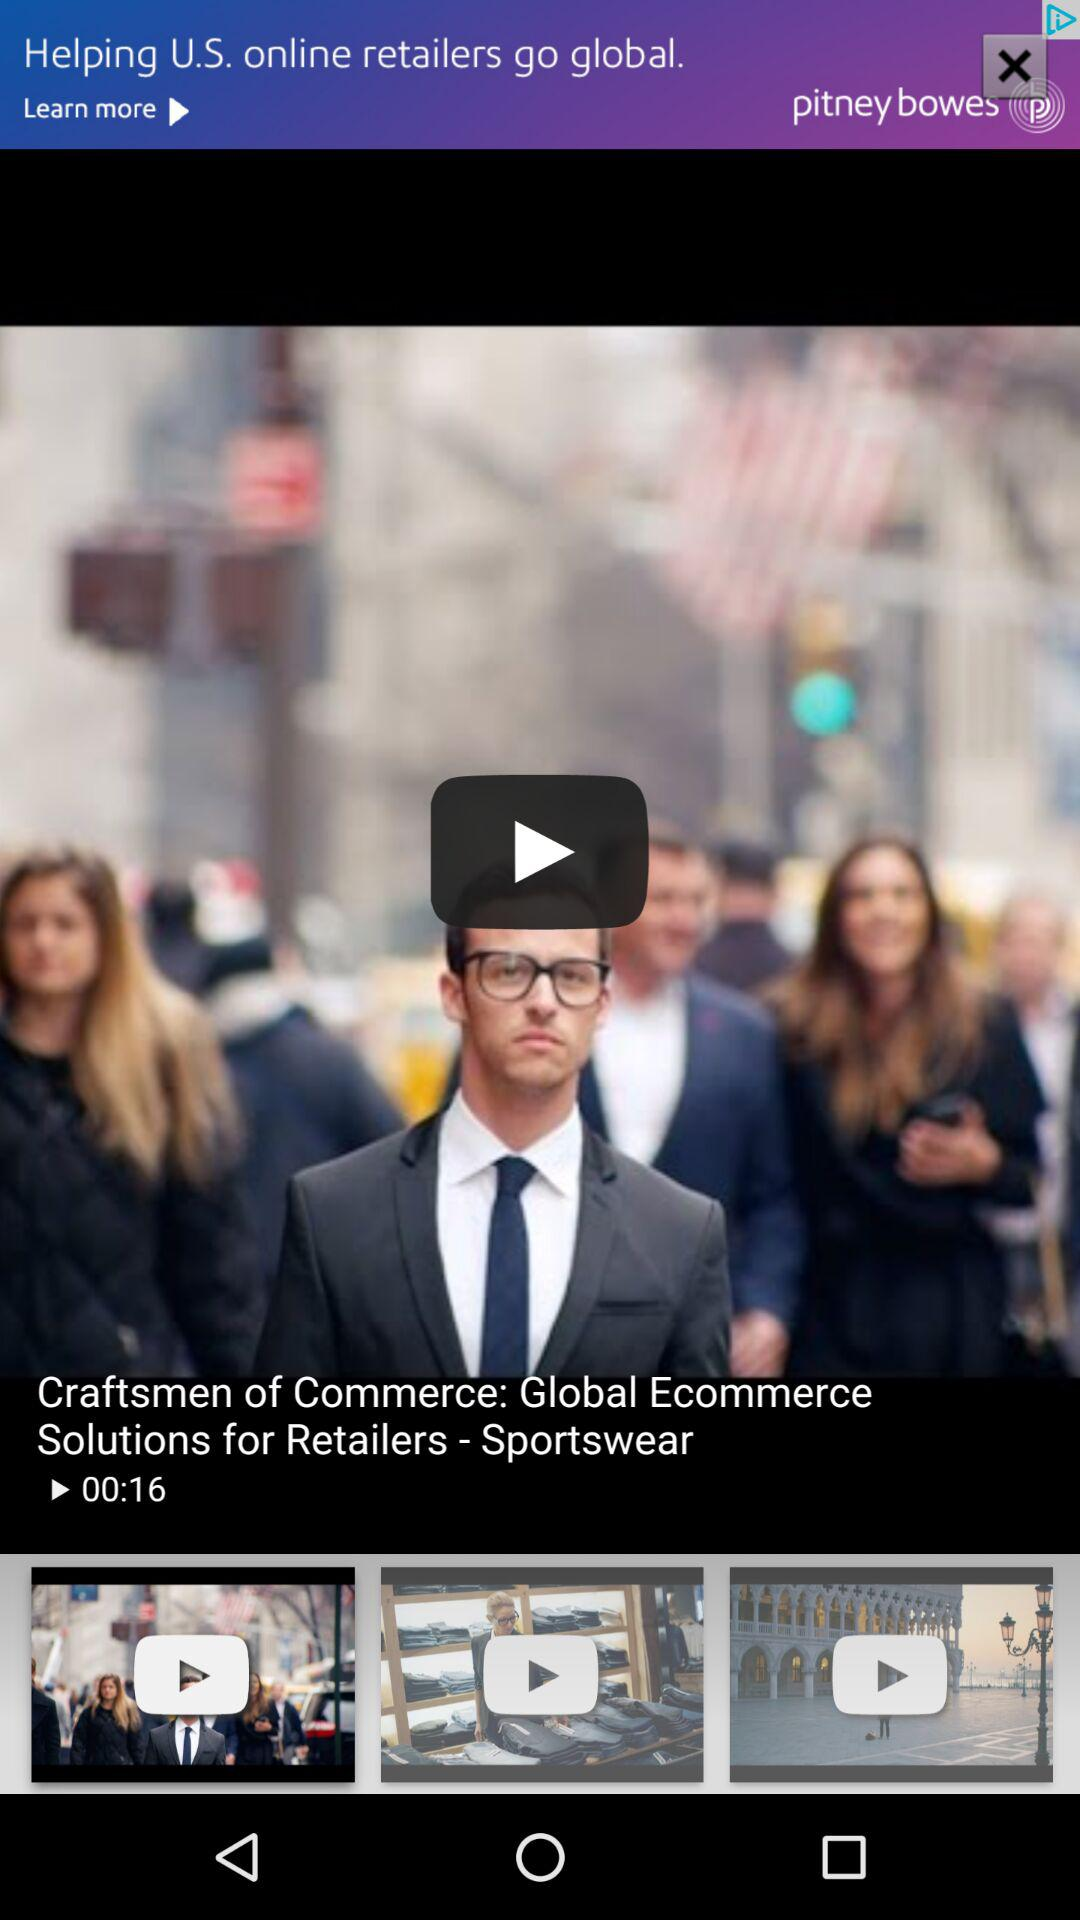What is the duration of the video "Craftsmen of Commerce: Global Ecommerce Solutions for Retailers - Sportswear"? The duration is 16 seconds. 